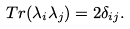<formula> <loc_0><loc_0><loc_500><loc_500>T r ( \lambda _ { i } \lambda _ { j } ) = 2 \delta _ { i j } .</formula> 